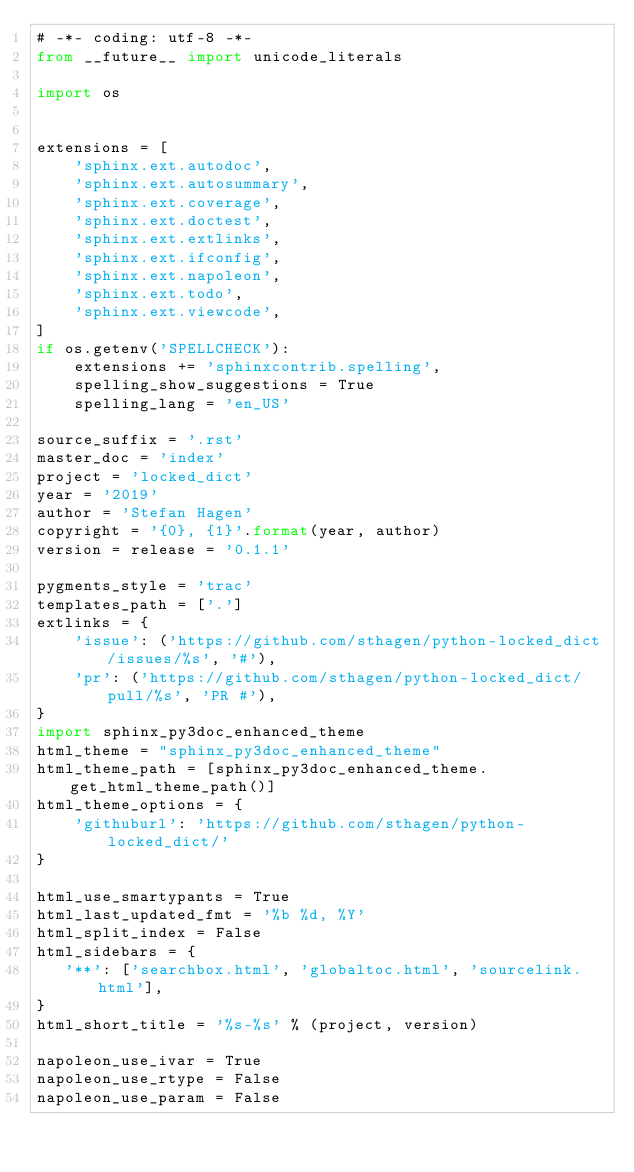<code> <loc_0><loc_0><loc_500><loc_500><_Python_># -*- coding: utf-8 -*-
from __future__ import unicode_literals

import os


extensions = [
    'sphinx.ext.autodoc',
    'sphinx.ext.autosummary',
    'sphinx.ext.coverage',
    'sphinx.ext.doctest',
    'sphinx.ext.extlinks',
    'sphinx.ext.ifconfig',
    'sphinx.ext.napoleon',
    'sphinx.ext.todo',
    'sphinx.ext.viewcode',
]
if os.getenv('SPELLCHECK'):
    extensions += 'sphinxcontrib.spelling',
    spelling_show_suggestions = True
    spelling_lang = 'en_US'

source_suffix = '.rst'
master_doc = 'index'
project = 'locked_dict'
year = '2019'
author = 'Stefan Hagen'
copyright = '{0}, {1}'.format(year, author)
version = release = '0.1.1'

pygments_style = 'trac'
templates_path = ['.']
extlinks = {
    'issue': ('https://github.com/sthagen/python-locked_dict/issues/%s', '#'),
    'pr': ('https://github.com/sthagen/python-locked_dict/pull/%s', 'PR #'),
}
import sphinx_py3doc_enhanced_theme
html_theme = "sphinx_py3doc_enhanced_theme"
html_theme_path = [sphinx_py3doc_enhanced_theme.get_html_theme_path()]
html_theme_options = {
    'githuburl': 'https://github.com/sthagen/python-locked_dict/'
}

html_use_smartypants = True
html_last_updated_fmt = '%b %d, %Y'
html_split_index = False
html_sidebars = {
   '**': ['searchbox.html', 'globaltoc.html', 'sourcelink.html'],
}
html_short_title = '%s-%s' % (project, version)

napoleon_use_ivar = True
napoleon_use_rtype = False
napoleon_use_param = False
</code> 